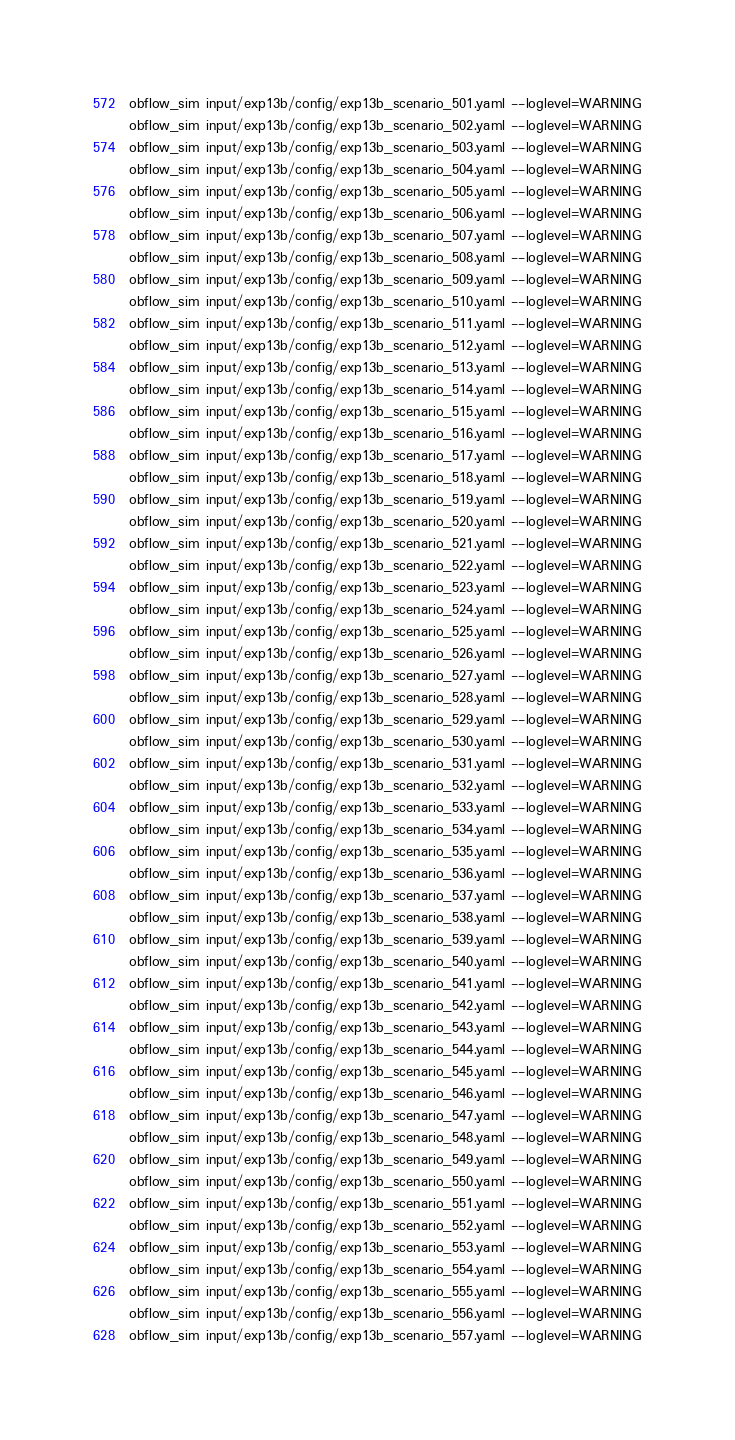Convert code to text. <code><loc_0><loc_0><loc_500><loc_500><_Bash_>obflow_sim input/exp13b/config/exp13b_scenario_501.yaml --loglevel=WARNING
obflow_sim input/exp13b/config/exp13b_scenario_502.yaml --loglevel=WARNING
obflow_sim input/exp13b/config/exp13b_scenario_503.yaml --loglevel=WARNING
obflow_sim input/exp13b/config/exp13b_scenario_504.yaml --loglevel=WARNING
obflow_sim input/exp13b/config/exp13b_scenario_505.yaml --loglevel=WARNING
obflow_sim input/exp13b/config/exp13b_scenario_506.yaml --loglevel=WARNING
obflow_sim input/exp13b/config/exp13b_scenario_507.yaml --loglevel=WARNING
obflow_sim input/exp13b/config/exp13b_scenario_508.yaml --loglevel=WARNING
obflow_sim input/exp13b/config/exp13b_scenario_509.yaml --loglevel=WARNING
obflow_sim input/exp13b/config/exp13b_scenario_510.yaml --loglevel=WARNING
obflow_sim input/exp13b/config/exp13b_scenario_511.yaml --loglevel=WARNING
obflow_sim input/exp13b/config/exp13b_scenario_512.yaml --loglevel=WARNING
obflow_sim input/exp13b/config/exp13b_scenario_513.yaml --loglevel=WARNING
obflow_sim input/exp13b/config/exp13b_scenario_514.yaml --loglevel=WARNING
obflow_sim input/exp13b/config/exp13b_scenario_515.yaml --loglevel=WARNING
obflow_sim input/exp13b/config/exp13b_scenario_516.yaml --loglevel=WARNING
obflow_sim input/exp13b/config/exp13b_scenario_517.yaml --loglevel=WARNING
obflow_sim input/exp13b/config/exp13b_scenario_518.yaml --loglevel=WARNING
obflow_sim input/exp13b/config/exp13b_scenario_519.yaml --loglevel=WARNING
obflow_sim input/exp13b/config/exp13b_scenario_520.yaml --loglevel=WARNING
obflow_sim input/exp13b/config/exp13b_scenario_521.yaml --loglevel=WARNING
obflow_sim input/exp13b/config/exp13b_scenario_522.yaml --loglevel=WARNING
obflow_sim input/exp13b/config/exp13b_scenario_523.yaml --loglevel=WARNING
obflow_sim input/exp13b/config/exp13b_scenario_524.yaml --loglevel=WARNING
obflow_sim input/exp13b/config/exp13b_scenario_525.yaml --loglevel=WARNING
obflow_sim input/exp13b/config/exp13b_scenario_526.yaml --loglevel=WARNING
obflow_sim input/exp13b/config/exp13b_scenario_527.yaml --loglevel=WARNING
obflow_sim input/exp13b/config/exp13b_scenario_528.yaml --loglevel=WARNING
obflow_sim input/exp13b/config/exp13b_scenario_529.yaml --loglevel=WARNING
obflow_sim input/exp13b/config/exp13b_scenario_530.yaml --loglevel=WARNING
obflow_sim input/exp13b/config/exp13b_scenario_531.yaml --loglevel=WARNING
obflow_sim input/exp13b/config/exp13b_scenario_532.yaml --loglevel=WARNING
obflow_sim input/exp13b/config/exp13b_scenario_533.yaml --loglevel=WARNING
obflow_sim input/exp13b/config/exp13b_scenario_534.yaml --loglevel=WARNING
obflow_sim input/exp13b/config/exp13b_scenario_535.yaml --loglevel=WARNING
obflow_sim input/exp13b/config/exp13b_scenario_536.yaml --loglevel=WARNING
obflow_sim input/exp13b/config/exp13b_scenario_537.yaml --loglevel=WARNING
obflow_sim input/exp13b/config/exp13b_scenario_538.yaml --loglevel=WARNING
obflow_sim input/exp13b/config/exp13b_scenario_539.yaml --loglevel=WARNING
obflow_sim input/exp13b/config/exp13b_scenario_540.yaml --loglevel=WARNING
obflow_sim input/exp13b/config/exp13b_scenario_541.yaml --loglevel=WARNING
obflow_sim input/exp13b/config/exp13b_scenario_542.yaml --loglevel=WARNING
obflow_sim input/exp13b/config/exp13b_scenario_543.yaml --loglevel=WARNING
obflow_sim input/exp13b/config/exp13b_scenario_544.yaml --loglevel=WARNING
obflow_sim input/exp13b/config/exp13b_scenario_545.yaml --loglevel=WARNING
obflow_sim input/exp13b/config/exp13b_scenario_546.yaml --loglevel=WARNING
obflow_sim input/exp13b/config/exp13b_scenario_547.yaml --loglevel=WARNING
obflow_sim input/exp13b/config/exp13b_scenario_548.yaml --loglevel=WARNING
obflow_sim input/exp13b/config/exp13b_scenario_549.yaml --loglevel=WARNING
obflow_sim input/exp13b/config/exp13b_scenario_550.yaml --loglevel=WARNING
obflow_sim input/exp13b/config/exp13b_scenario_551.yaml --loglevel=WARNING
obflow_sim input/exp13b/config/exp13b_scenario_552.yaml --loglevel=WARNING
obflow_sim input/exp13b/config/exp13b_scenario_553.yaml --loglevel=WARNING
obflow_sim input/exp13b/config/exp13b_scenario_554.yaml --loglevel=WARNING
obflow_sim input/exp13b/config/exp13b_scenario_555.yaml --loglevel=WARNING
obflow_sim input/exp13b/config/exp13b_scenario_556.yaml --loglevel=WARNING
obflow_sim input/exp13b/config/exp13b_scenario_557.yaml --loglevel=WARNING</code> 